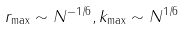Convert formula to latex. <formula><loc_0><loc_0><loc_500><loc_500>r _ { \max } \sim N ^ { - 1 / 6 } , k _ { \max } \sim N ^ { 1 / 6 }</formula> 